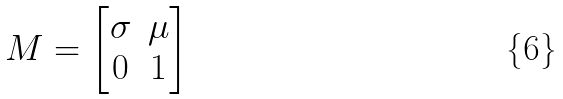Convert formula to latex. <formula><loc_0><loc_0><loc_500><loc_500>M = \begin{bmatrix} \sigma & \mu \\ 0 & 1 \end{bmatrix}</formula> 